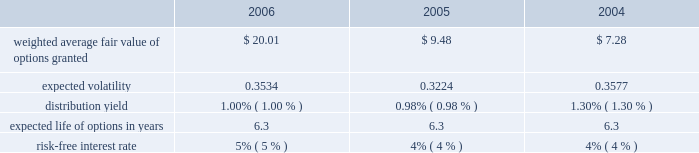The fair value for these options was estimated at the date of grant using a black-scholes option pricing model with the following weighted-average assumptions for 2006 , 2005 and 2004: .
The black-scholes option valuation model was developed for use in estimating the fair value of traded options which have no vesting restrictions and are fully transferable .
In addition , option valuation models require the input of highly subjective assumptions , including the expected stock price volatility .
Because the company 2019s employee stock options have characteristics significantly different from those of traded options , and because changes in the subjective input assumptions can materially affect the fair value estimate , in management 2019s opinion , the existing models do not necessarily provide a reliable single measure of the fair value of its employee stock options .
The total fair value of shares vested during 2006 , 2005 , and 2004 was $ 9413 , $ 8249 , and $ 6418 respectively .
The aggregate intrinsic values of options outstanding and exercisable at december 30 , 2006 were $ 204.1 million and $ 100.2 million , respectively .
The aggregate intrinsic value of options exercised during the year ended december 30 , 2006 was $ 42.8 million .
Aggregate intrinsic value represents the positive difference between the company 2019s closing stock price on the last trading day of the fiscal period , which was $ 55.66 on december 29 , 2006 , and the exercise price multiplied by the number of options outstanding .
As of december 30 , 2006 , there was $ 64.2 million of total unrecognized compensation cost related to unvested share-based compensation awards granted to employees under the option plans .
That cost is expected to be recognized over a period of five years .
Employee stock purchase plan the shareholders also adopted an employee stock purchase plan ( espp ) .
Up to 2000000 shares of common stock have been reserved for the espp .
Shares will be offered to employees at a price equal to the lesser of 85% ( 85 % ) of the fair market value of the stock on the date of purchase or 85% ( 85 % ) of the fair market value on the enrollment date .
The espp is intended to qualify as an 201cemployee stock purchase plan 201d under section 423 of the internal revenue code .
During 2006 , 2005 , and 2004 , 124693 , 112798 , and 117900 shares were purchased under the plan for a total purchase price of $ 3569 , $ 2824 , and $ 2691 , respectively .
At december 30 , 2006 , approximately 1116811 shares were available for future issuance. .
Considering the weighted average fair value of options , what was the decrease between shares that vested in 2006 and 2005? 
Rationale: it is the total fair value of options that vested in 2005 divided by its weighted average fair value also in 2005 minus the total fair value of options that vested in 2006 divided by its weighted average fair value in 2006 .
Computations: ((8249 / 9.48) - (9413 / 20.01))
Answer: 399.73289. 